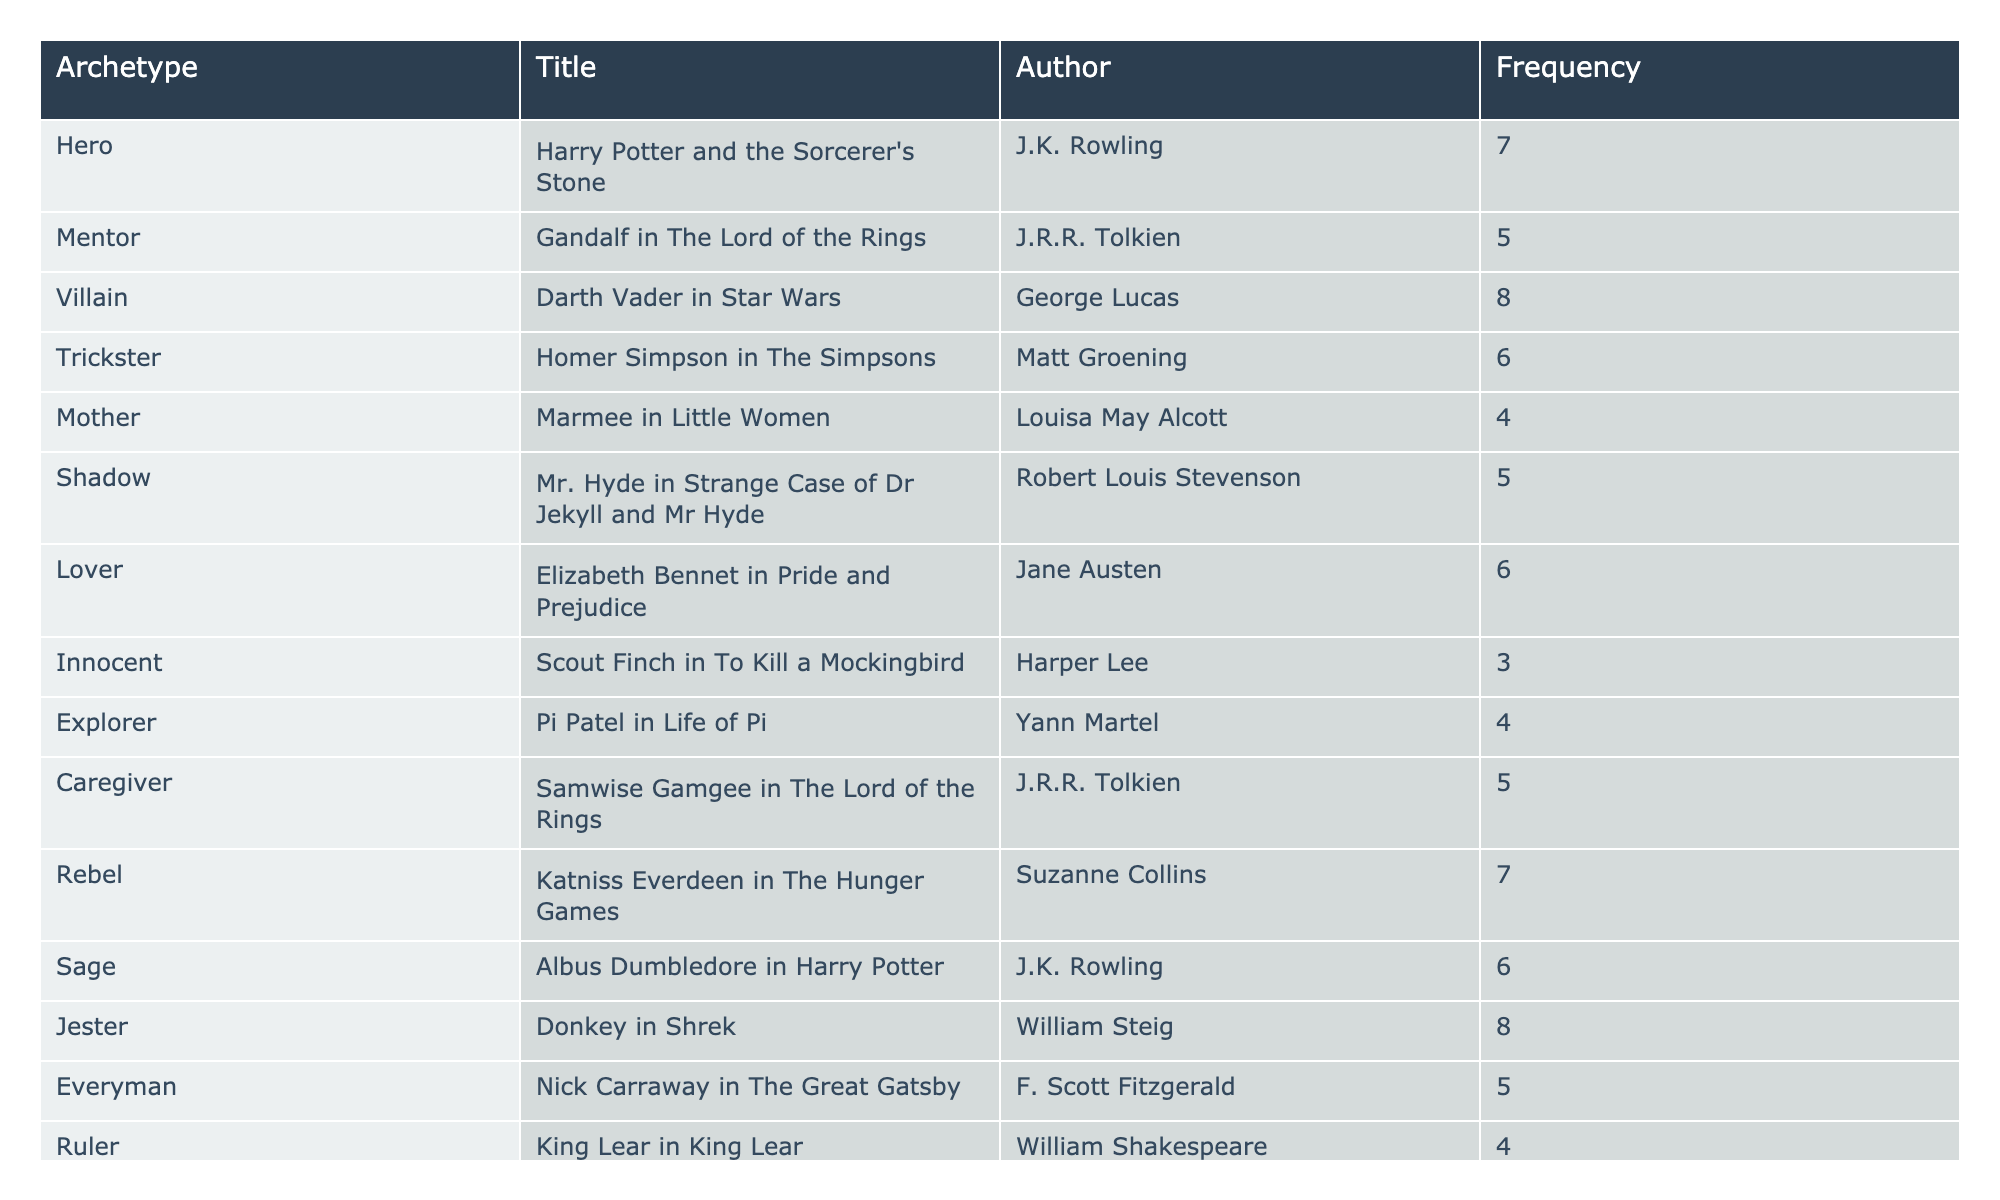What is the frequency of the Hero archetype in "Harry Potter and the Sorcerer's Stone"? The table indicates that the Hero archetype appears 7 times in "Harry Potter and the Sorcerer's Stone".
Answer: 7 Which character is associated with the Villain archetype, and how many times do they appear? Darth Vader is listed as the character associated with the Villain archetype, appearing 8 times.
Answer: Darth Vader, 8 What is the total frequency of the Caregiver and Mother archetypes combined? Caregiver has a frequency of 5 and Mother has a frequency of 4. Adding these together gives 5 + 4 = 9.
Answer: 9 Is there a character associated with the Trickster archetype? Yes, Homer Simpson is listed as the character associated with the Trickster archetype.
Answer: Yes Which archetype has the highest frequency, and what is that frequency? The Villain (Darth Vader) and Jester (Donkey) archetypes both have the highest frequency, which is 8.
Answer: Villain and Jester, 8 What is the average frequency of the archetypes listed in the table? To find the average, add the frequencies of all archetypes (7 + 5 + 8 + 6 + 4 + 5 + 6 + 3 + 4 + 5 + 7 + 6 + 8 + 5 + 4 + 3 = 81) and divide by the number of archetypes (16). So, 81 / 16 = 5.0625.
Answer: 5.0625 How many times does the character Scout Finch appear in "To Kill a Mockingbird"? Scout Finch is listed in the table with a frequency of 3.
Answer: 3 Is there a character with the Rebel archetype? If so, who is it? Yes, Katniss Everdeen is the character associated with the Rebel archetype.
Answer: Yes, Katniss Everdeen What is the difference in frequency between the Explorer and Innocent archetypes? Explorer has a frequency of 4 and Innocent has a frequency of 3. The difference is 4 - 3 = 1.
Answer: 1 Which archetypes have a frequency greater than or equal to 6? The archetypes with a frequency of 6 or more are Hero (7), Villain (8), Trickster (6), Lover (6), Sage (6), and Jester (8).
Answer: Hero, Villain, Trickster, Lover, Sage, Jester How many archetypes have a frequency of less than 4? The table shows that the Creator and Innocent archetypes have frequencies of 3; there are 2 archetypes with frequencies less than 4.
Answer: 2 